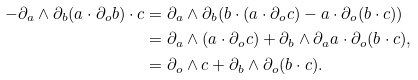<formula> <loc_0><loc_0><loc_500><loc_500>- \partial _ { a } \wedge \partial _ { b } ( a \cdot \partial _ { o } b ) \cdot c & = \partial _ { a } \wedge \partial _ { b } ( b \cdot ( a \cdot \partial _ { o } c ) - a \cdot \partial _ { o } ( b \cdot c ) ) \\ & = \partial _ { a } \wedge ( a \cdot \partial _ { o } c ) + \partial _ { b } \wedge \partial _ { a } a \cdot \partial _ { o } ( b \cdot c ) , \\ & = \partial _ { o } \wedge c + \partial _ { b } \wedge \partial _ { o } ( b \cdot c ) .</formula> 